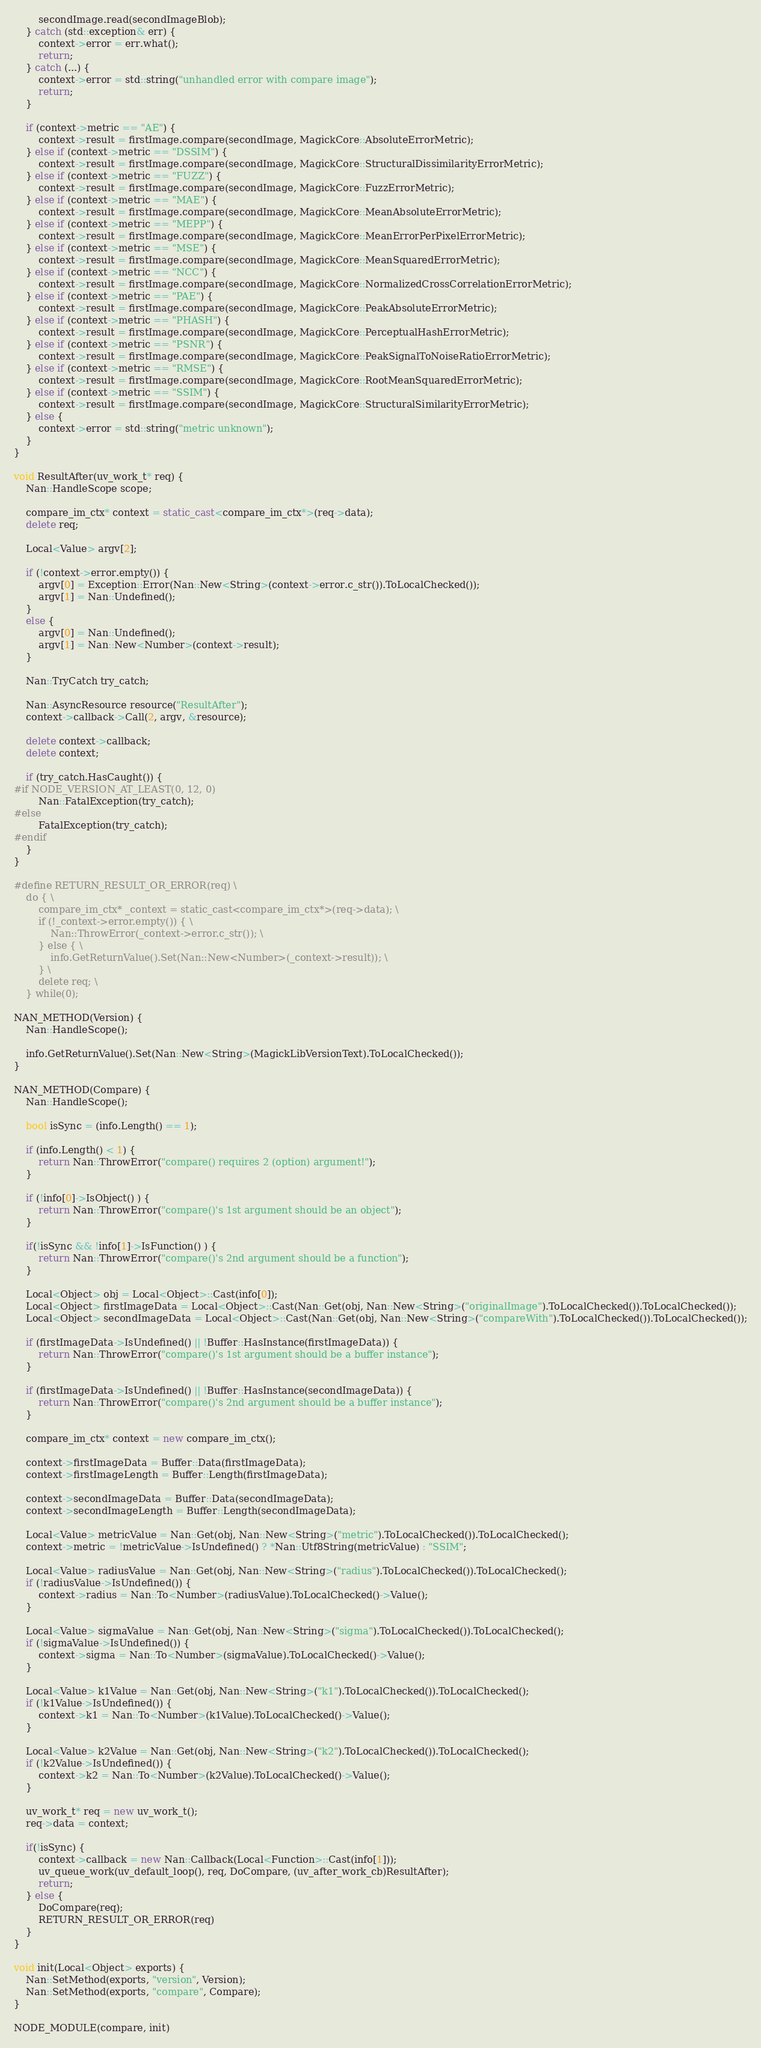Convert code to text. <code><loc_0><loc_0><loc_500><loc_500><_C++_>        secondImage.read(secondImageBlob);
    } catch (std::exception& err) {
        context->error = err.what();
        return;
    } catch (...) {
        context->error = std::string("unhandled error with compare image");
        return;
    }

    if (context->metric == "AE") {
        context->result = firstImage.compare(secondImage, MagickCore::AbsoluteErrorMetric);
    } else if (context->metric == "DSSIM") {
        context->result = firstImage.compare(secondImage, MagickCore::StructuralDissimilarityErrorMetric);
    } else if (context->metric == "FUZZ") {
        context->result = firstImage.compare(secondImage, MagickCore::FuzzErrorMetric);
    } else if (context->metric == "MAE") {
        context->result = firstImage.compare(secondImage, MagickCore::MeanAbsoluteErrorMetric);
    } else if (context->metric == "MEPP") {
        context->result = firstImage.compare(secondImage, MagickCore::MeanErrorPerPixelErrorMetric);
    } else if (context->metric == "MSE") {
        context->result = firstImage.compare(secondImage, MagickCore::MeanSquaredErrorMetric);
    } else if (context->metric == "NCC") {
        context->result = firstImage.compare(secondImage, MagickCore::NormalizedCrossCorrelationErrorMetric);
    } else if (context->metric == "PAE") {
        context->result = firstImage.compare(secondImage, MagickCore::PeakAbsoluteErrorMetric);
    } else if (context->metric == "PHASH") {
        context->result = firstImage.compare(secondImage, MagickCore::PerceptualHashErrorMetric);
    } else if (context->metric == "PSNR") {
        context->result = firstImage.compare(secondImage, MagickCore::PeakSignalToNoiseRatioErrorMetric);
    } else if (context->metric == "RMSE") {
        context->result = firstImage.compare(secondImage, MagickCore::RootMeanSquaredErrorMetric);
    } else if (context->metric == "SSIM") {
        context->result = firstImage.compare(secondImage, MagickCore::StructuralSimilarityErrorMetric);
    } else {
        context->error = std::string("metric unknown");
    }
}

void ResultAfter(uv_work_t* req) {
    Nan::HandleScope scope;

    compare_im_ctx* context = static_cast<compare_im_ctx*>(req->data);
    delete req;

    Local<Value> argv[2];

    if (!context->error.empty()) {
        argv[0] = Exception::Error(Nan::New<String>(context->error.c_str()).ToLocalChecked());
        argv[1] = Nan::Undefined();
    }
    else {
        argv[0] = Nan::Undefined();
        argv[1] = Nan::New<Number>(context->result);
    }

    Nan::TryCatch try_catch;

    Nan::AsyncResource resource("ResultAfter");
    context->callback->Call(2, argv, &resource);

    delete context->callback;
    delete context;

    if (try_catch.HasCaught()) {
#if NODE_VERSION_AT_LEAST(0, 12, 0)
        Nan::FatalException(try_catch);
#else
        FatalException(try_catch);
#endif
    }
}

#define RETURN_RESULT_OR_ERROR(req) \
    do { \
        compare_im_ctx* _context = static_cast<compare_im_ctx*>(req->data); \
        if (!_context->error.empty()) { \
            Nan::ThrowError(_context->error.c_str()); \
        } else { \
            info.GetReturnValue().Set(Nan::New<Number>(_context->result)); \
        } \
        delete req; \
    } while(0);

NAN_METHOD(Version) {
    Nan::HandleScope();

    info.GetReturnValue().Set(Nan::New<String>(MagickLibVersionText).ToLocalChecked());
}

NAN_METHOD(Compare) {
    Nan::HandleScope();

    bool isSync = (info.Length() == 1);

    if (info.Length() < 1) {
        return Nan::ThrowError("compare() requires 2 (option) argument!");
    }

    if (!info[0]->IsObject() ) {
        return Nan::ThrowError("compare()'s 1st argument should be an object");
    }

    if(!isSync && !info[1]->IsFunction() ) {
        return Nan::ThrowError("compare()'s 2nd argument should be a function");
    }

    Local<Object> obj = Local<Object>::Cast(info[0]);
    Local<Object> firstImageData = Local<Object>::Cast(Nan::Get(obj, Nan::New<String>("originalImage").ToLocalChecked()).ToLocalChecked());
    Local<Object> secondImageData = Local<Object>::Cast(Nan::Get(obj, Nan::New<String>("compareWith").ToLocalChecked()).ToLocalChecked());

    if (firstImageData->IsUndefined() || !Buffer::HasInstance(firstImageData)) {
        return Nan::ThrowError("compare()'s 1st argument should be a buffer instance");
    }

    if (firstImageData->IsUndefined() || !Buffer::HasInstance(secondImageData)) {
        return Nan::ThrowError("compare()'s 2nd argument should be a buffer instance");
    }

    compare_im_ctx* context = new compare_im_ctx();

    context->firstImageData = Buffer::Data(firstImageData);
    context->firstImageLength = Buffer::Length(firstImageData);

    context->secondImageData = Buffer::Data(secondImageData);
    context->secondImageLength = Buffer::Length(secondImageData);

    Local<Value> metricValue = Nan::Get(obj, Nan::New<String>("metric").ToLocalChecked()).ToLocalChecked();
    context->metric = !metricValue->IsUndefined() ? *Nan::Utf8String(metricValue) : "SSIM";

    Local<Value> radiusValue = Nan::Get(obj, Nan::New<String>("radius").ToLocalChecked()).ToLocalChecked();
    if (!radiusValue->IsUndefined()) {
        context->radius = Nan::To<Number>(radiusValue).ToLocalChecked()->Value();
    }

    Local<Value> sigmaValue = Nan::Get(obj, Nan::New<String>("sigma").ToLocalChecked()).ToLocalChecked();
    if (!sigmaValue->IsUndefined()) {
        context->sigma = Nan::To<Number>(sigmaValue).ToLocalChecked()->Value();
    }

    Local<Value> k1Value = Nan::Get(obj, Nan::New<String>("k1").ToLocalChecked()).ToLocalChecked();
    if (!k1Value->IsUndefined()) {
        context->k1 = Nan::To<Number>(k1Value).ToLocalChecked()->Value();
    }

    Local<Value> k2Value = Nan::Get(obj, Nan::New<String>("k2").ToLocalChecked()).ToLocalChecked();
    if (!k2Value->IsUndefined()) {
        context->k2 = Nan::To<Number>(k2Value).ToLocalChecked()->Value();
    }

    uv_work_t* req = new uv_work_t();
    req->data = context;

    if(!isSync) {
        context->callback = new Nan::Callback(Local<Function>::Cast(info[1]));
        uv_queue_work(uv_default_loop(), req, DoCompare, (uv_after_work_cb)ResultAfter);
        return;
    } else {
        DoCompare(req);
        RETURN_RESULT_OR_ERROR(req)
    }
}

void init(Local<Object> exports) {
    Nan::SetMethod(exports, "version", Version);
    Nan::SetMethod(exports, "compare", Compare);
}

NODE_MODULE(compare, init)
</code> 